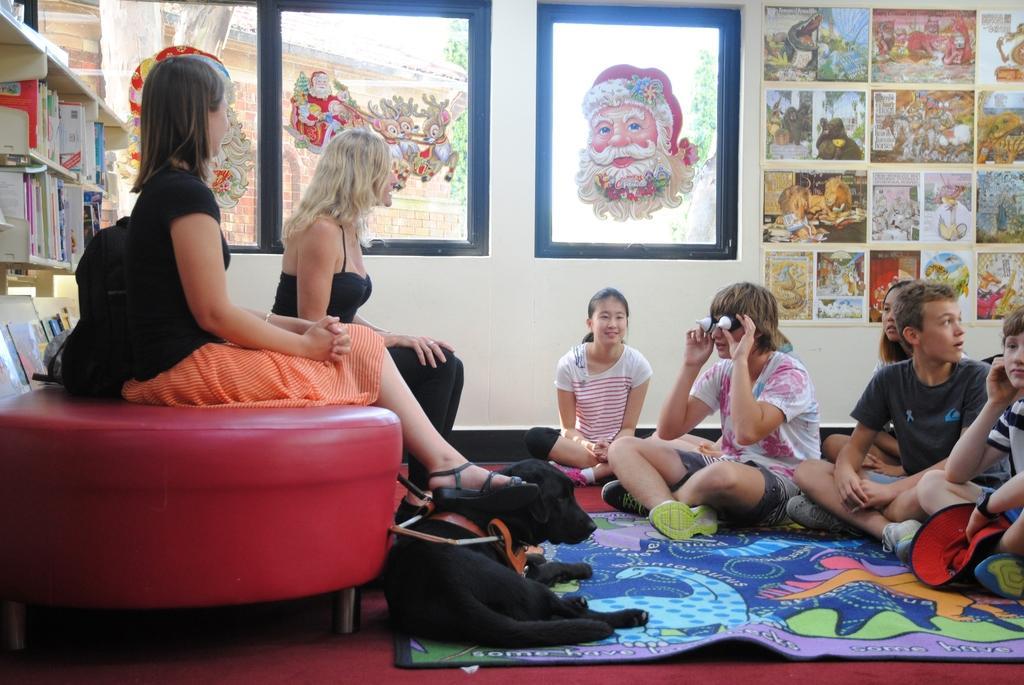Describe this image in one or two sentences. In this picture these two persons sitting on the chair. These persons sitting on the floor. This is dog. On the background we can see wall,Painting on glass window, posters. This is cupboard. In a cupboard we can see books. This is floor. From this glass window we can see wall. 